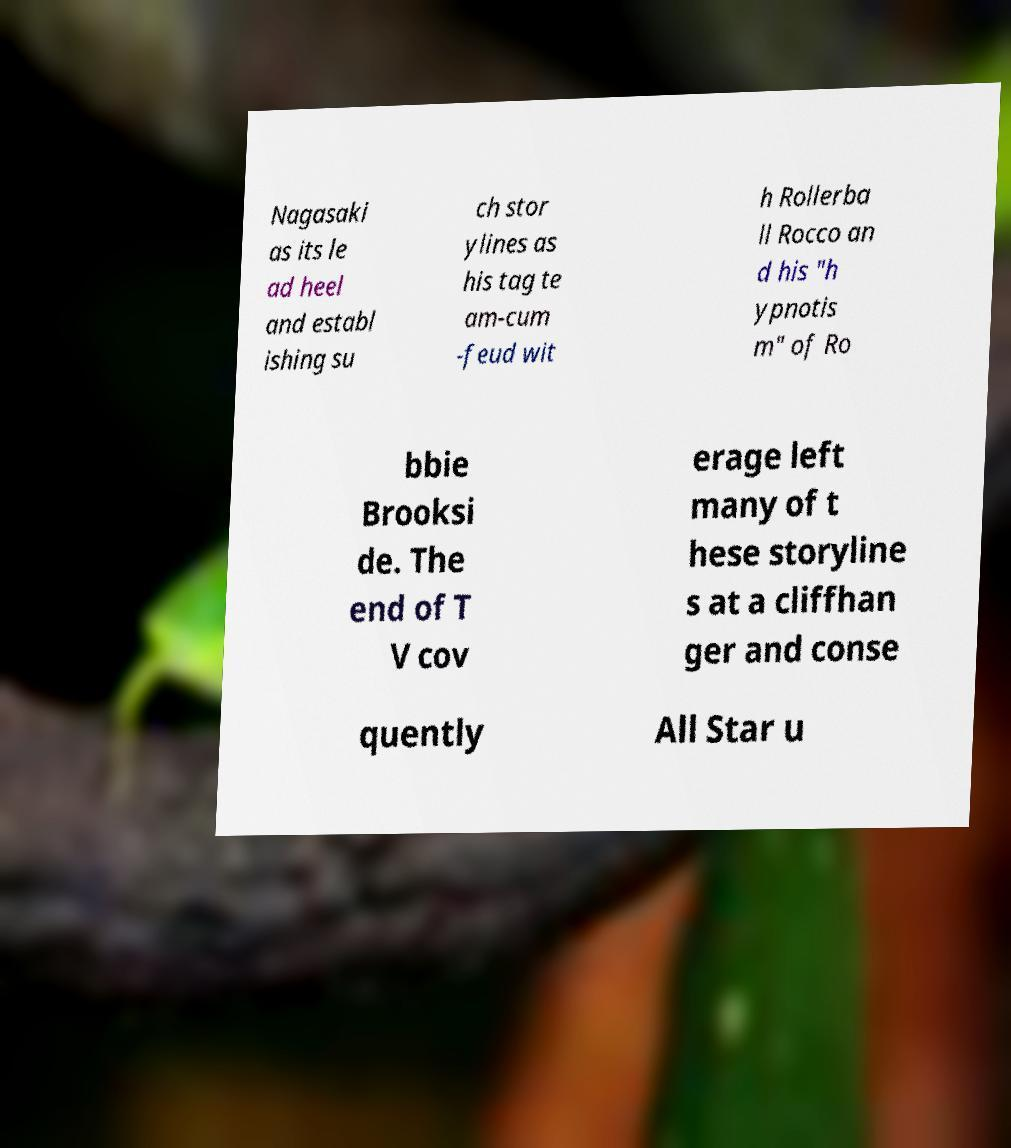There's text embedded in this image that I need extracted. Can you transcribe it verbatim? Nagasaki as its le ad heel and establ ishing su ch stor ylines as his tag te am-cum -feud wit h Rollerba ll Rocco an d his "h ypnotis m" of Ro bbie Brooksi de. The end of T V cov erage left many of t hese storyline s at a cliffhan ger and conse quently All Star u 